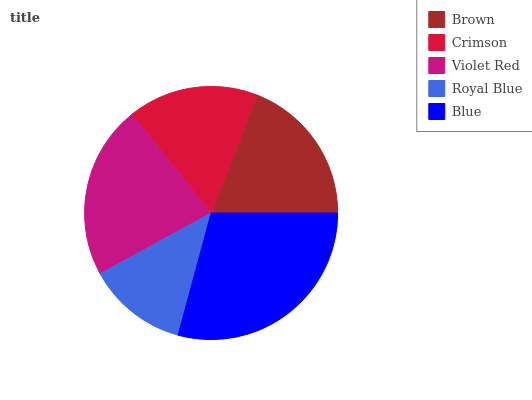Is Royal Blue the minimum?
Answer yes or no. Yes. Is Blue the maximum?
Answer yes or no. Yes. Is Crimson the minimum?
Answer yes or no. No. Is Crimson the maximum?
Answer yes or no. No. Is Brown greater than Crimson?
Answer yes or no. Yes. Is Crimson less than Brown?
Answer yes or no. Yes. Is Crimson greater than Brown?
Answer yes or no. No. Is Brown less than Crimson?
Answer yes or no. No. Is Brown the high median?
Answer yes or no. Yes. Is Brown the low median?
Answer yes or no. Yes. Is Violet Red the high median?
Answer yes or no. No. Is Violet Red the low median?
Answer yes or no. No. 